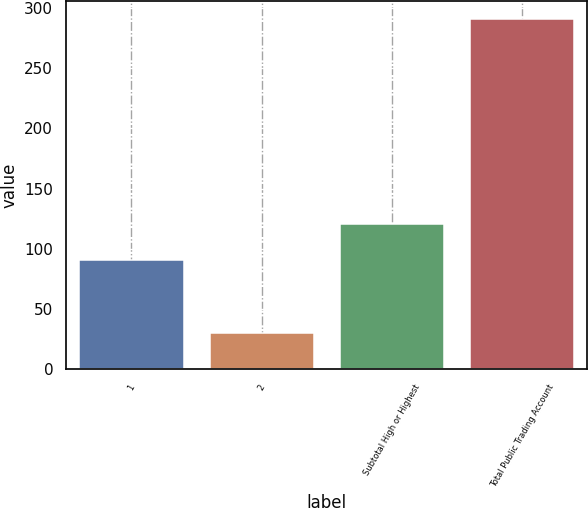Convert chart. <chart><loc_0><loc_0><loc_500><loc_500><bar_chart><fcel>1<fcel>2<fcel>Subtotal High or Highest<fcel>Total Public Trading Account<nl><fcel>91<fcel>30<fcel>121<fcel>291<nl></chart> 